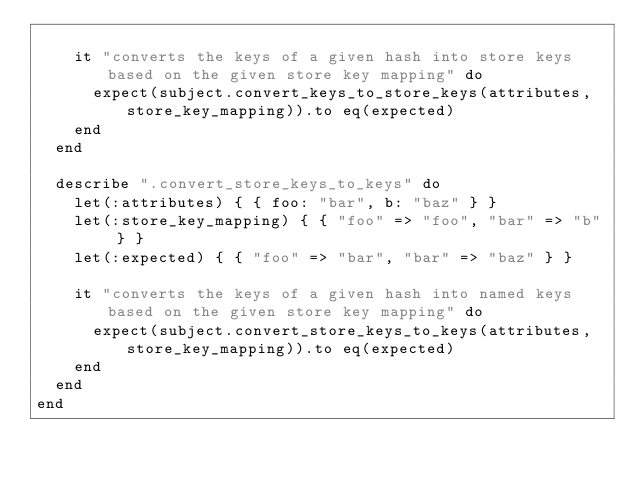Convert code to text. <code><loc_0><loc_0><loc_500><loc_500><_Ruby_>
    it "converts the keys of a given hash into store keys based on the given store key mapping" do
      expect(subject.convert_keys_to_store_keys(attributes, store_key_mapping)).to eq(expected)
    end
  end

  describe ".convert_store_keys_to_keys" do
    let(:attributes) { { foo: "bar", b: "baz" } }
    let(:store_key_mapping) { { "foo" => "foo", "bar" => "b" } }
    let(:expected) { { "foo" => "bar", "bar" => "baz" } }

    it "converts the keys of a given hash into named keys based on the given store key mapping" do
      expect(subject.convert_store_keys_to_keys(attributes, store_key_mapping)).to eq(expected)
    end
  end
end
</code> 